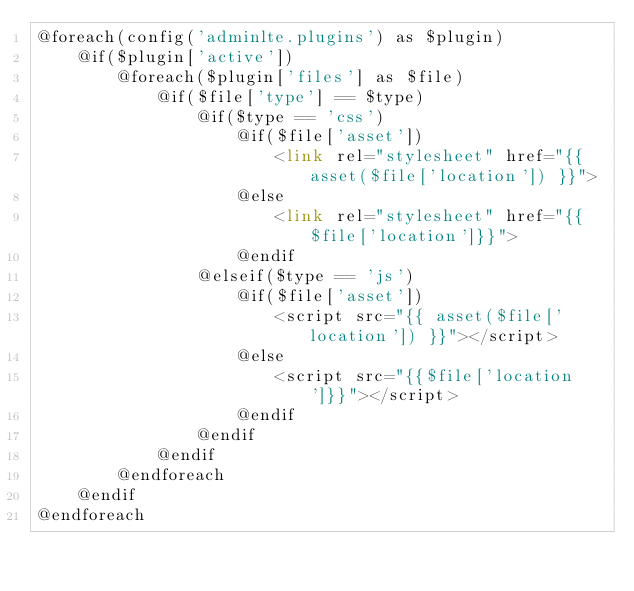Convert code to text. <code><loc_0><loc_0><loc_500><loc_500><_PHP_>@foreach(config('adminlte.plugins') as $plugin)
    @if($plugin['active'])
        @foreach($plugin['files'] as $file)
            @if($file['type'] == $type)
                @if($type == 'css')
                    @if($file['asset'])
                        <link rel="stylesheet" href="{{ asset($file['location']) }}">
                    @else
                        <link rel="stylesheet" href="{{$file['location']}}">
                    @endif
                @elseif($type == 'js')
                    @if($file['asset'])
                        <script src="{{ asset($file['location']) }}"></script>
                    @else
                        <script src="{{$file['location']}}"></script>
                    @endif
                @endif
            @endif
        @endforeach
    @endif
@endforeach
</code> 